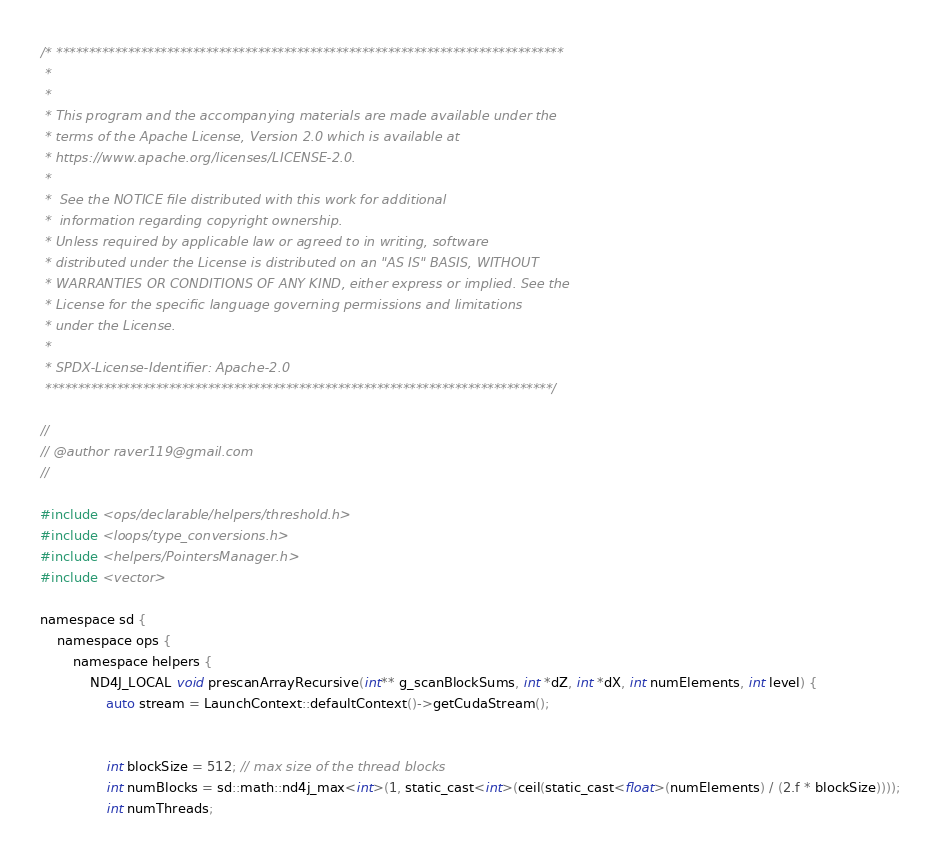<code> <loc_0><loc_0><loc_500><loc_500><_Cuda_>/* ******************************************************************************
 *
 *
 * This program and the accompanying materials are made available under the
 * terms of the Apache License, Version 2.0 which is available at
 * https://www.apache.org/licenses/LICENSE-2.0.
 *
 *  See the NOTICE file distributed with this work for additional
 *  information regarding copyright ownership.
 * Unless required by applicable law or agreed to in writing, software
 * distributed under the License is distributed on an "AS IS" BASIS, WITHOUT
 * WARRANTIES OR CONDITIONS OF ANY KIND, either express or implied. See the
 * License for the specific language governing permissions and limitations
 * under the License.
 *
 * SPDX-License-Identifier: Apache-2.0
 ******************************************************************************/

//
// @author raver119@gmail.com
//

#include <ops/declarable/helpers/threshold.h>
#include <loops/type_conversions.h>
#include <helpers/PointersManager.h>
#include <vector>

namespace sd {
    namespace ops {
        namespace helpers {
            ND4J_LOCAL void prescanArrayRecursive(int** g_scanBlockSums, int *dZ, int *dX, int numElements, int level) {
                auto stream = LaunchContext::defaultContext()->getCudaStream();


                int blockSize = 512; // max size of the thread blocks
                int numBlocks = sd::math::nd4j_max<int>(1, static_cast<int>(ceil(static_cast<float>(numElements) / (2.f * blockSize))));
                int numThreads;
</code> 